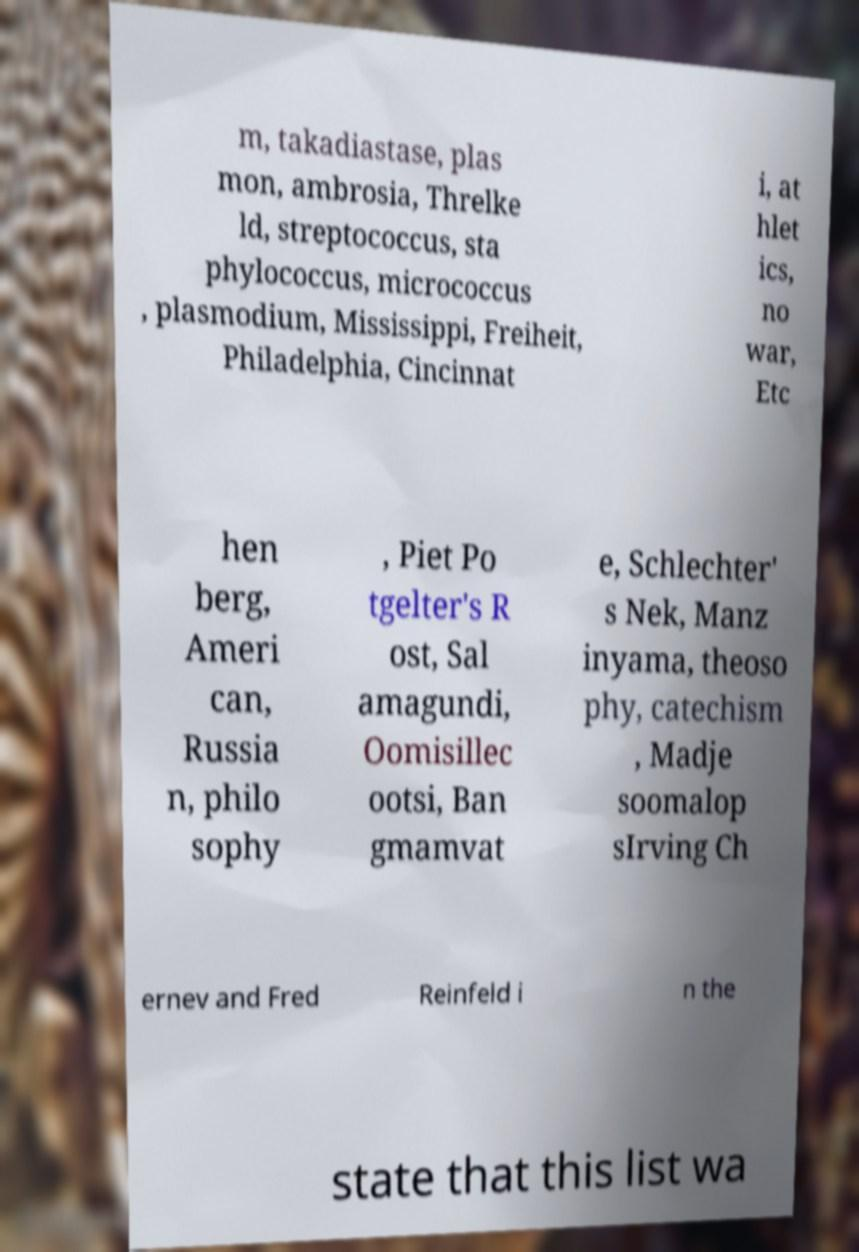I need the written content from this picture converted into text. Can you do that? m, takadiastase, plas mon, ambrosia, Threlke ld, streptococcus, sta phylococcus, micrococcus , plasmodium, Mississippi, Freiheit, Philadelphia, Cincinnat i, at hlet ics, no war, Etc hen berg, Ameri can, Russia n, philo sophy , Piet Po tgelter's R ost, Sal amagundi, Oomisillec ootsi, Ban gmamvat e, Schlechter' s Nek, Manz inyama, theoso phy, catechism , Madje soomalop sIrving Ch ernev and Fred Reinfeld i n the state that this list wa 